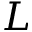Convert formula to latex. <formula><loc_0><loc_0><loc_500><loc_500>L</formula> 